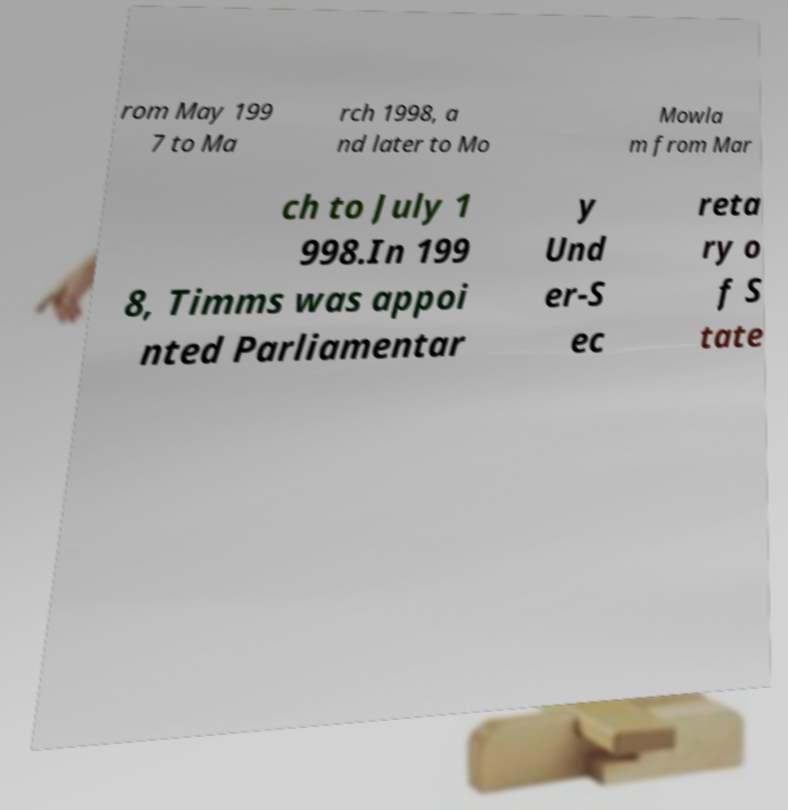What messages or text are displayed in this image? I need them in a readable, typed format. rom May 199 7 to Ma rch 1998, a nd later to Mo Mowla m from Mar ch to July 1 998.In 199 8, Timms was appoi nted Parliamentar y Und er-S ec reta ry o f S tate 